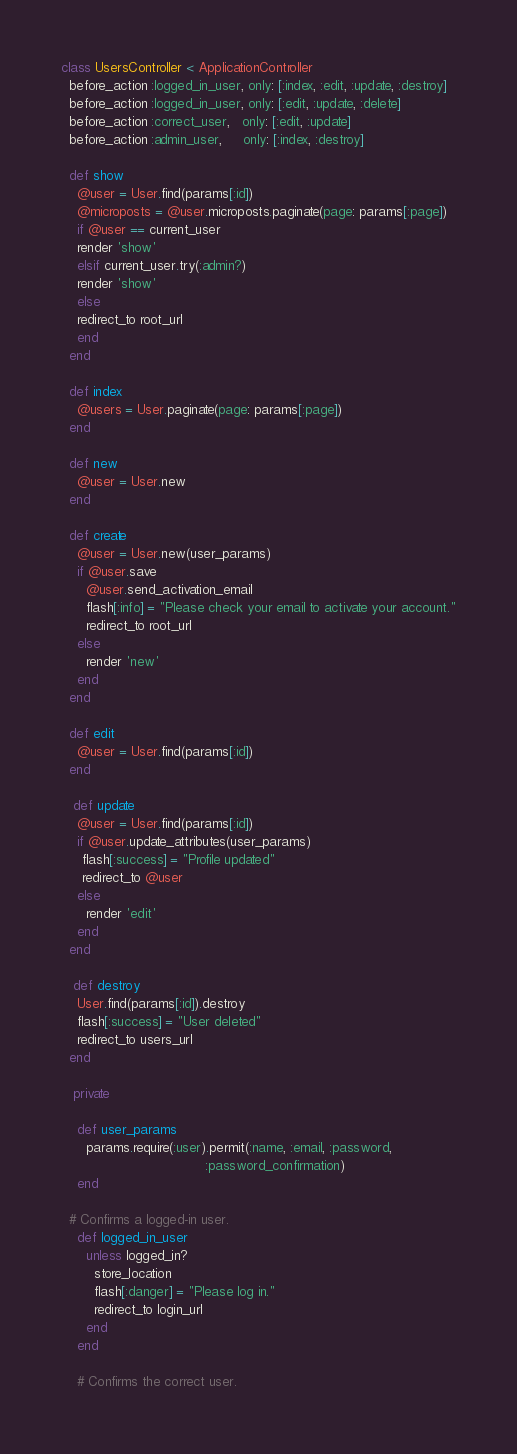<code> <loc_0><loc_0><loc_500><loc_500><_Ruby_>class UsersController < ApplicationController
  before_action :logged_in_user, only: [:index, :edit, :update, :destroy]
  before_action :logged_in_user, only: [:edit, :update, :delete]
  before_action :correct_user,   only: [:edit, :update]
  before_action :admin_user,     only: [:index, :destroy]

  def show
    @user = User.find(params[:id])
    @microposts = @user.microposts.paginate(page: params[:page])
    if @user == current_user
	render 'show'
    elsif current_user.try(:admin?)
	render 'show'
    else
	redirect_to root_url
    end
  end

  def index
    @users = User.paginate(page: params[:page])
  end

  def new
    @user = User.new
  end

  def create
    @user = User.new(user_params)
    if @user.save
      @user.send_activation_email
      flash[:info] = "Please check your email to activate your account."
      redirect_to root_url
    else
      render 'new'
    end
  end

  def edit
    @user = User.find(params[:id])
  end

   def update
    @user = User.find(params[:id])
    if @user.update_attributes(user_params)
     flash[:success] = "Profile updated"
     redirect_to @user
    else
      render 'edit'
    end
  end

   def destroy
    User.find(params[:id]).destroy
    flash[:success] = "User deleted"
    redirect_to users_url
  end

   private

    def user_params
      params.require(:user).permit(:name, :email, :password,
                                   :password_confirmation)
    end

  # Confirms a logged-in user.
    def logged_in_user
      unless logged_in?
        store_location
        flash[:danger] = "Please log in."
        redirect_to login_url
      end
    end

    # Confirms the correct user.</code> 